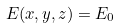Convert formula to latex. <formula><loc_0><loc_0><loc_500><loc_500>E ( x , y , z ) = E _ { 0 }</formula> 